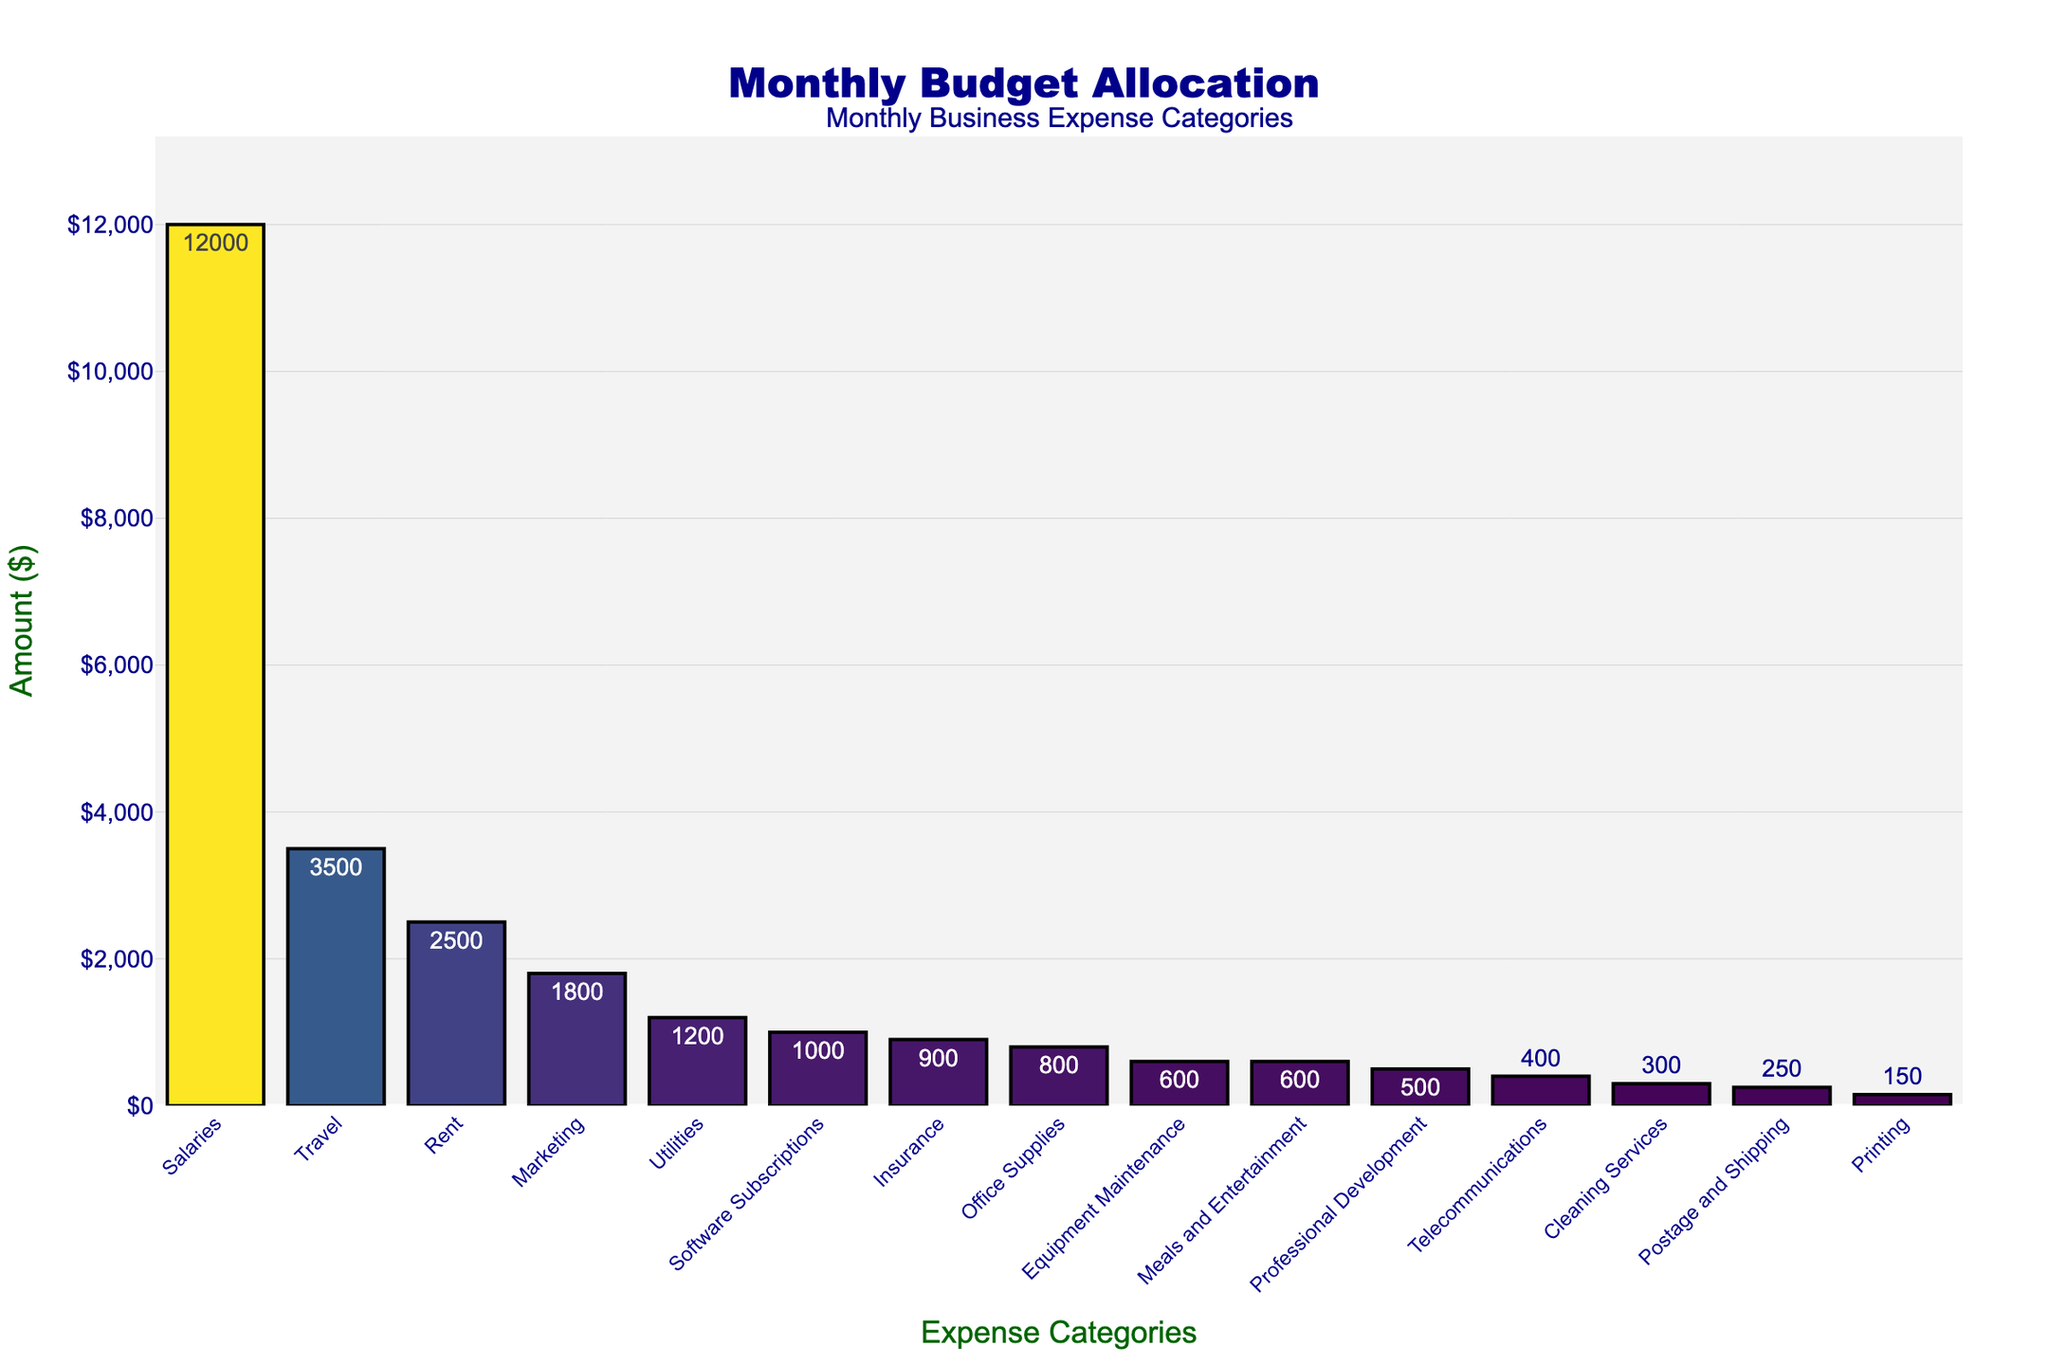Which expense category has the highest budget allocation? The figure shows bars representing each expense category with their respective amounts. The highest bar corresponds to the "Salaries" category.
Answer: Salaries What is the sum of the budget allocated for Travel, Rent, and Marketing? Add the amounts allocated for Travel ($3500), Rent ($2500), and Marketing ($1800). The total is 3500 + 2500 + 1800 = 7800.
Answer: 7800 How much more is allocated to Rent compared to Office Supplies? The amount for Rent is $2500 and for Office Supplies is $800. Subtract the amount for Office Supplies from the amount for Rent: 2500 - 800 = 1700.
Answer: 1700 Which expense categories are allocated less than $500? From the bar chart, the categories with allocations less than $500 are Professional Development, Telecommunications, Cleaning Services, Postage and Shipping, and Printing.
Answer: Professional Development, Telecommunications, Cleaning Services, Postage and Shipping, Printing Which color shade represents the category with the second lowest budget allocation? The second lowest budget allocation corresponds to Printing with $150. This bar is in a darker shade due to the Viridis color scale.
Answer: Dark shade What is the average amount allocated across all expense categories? Sum all the amounts and divide by the number of categories: (3500 + 800 + 1200 + 2500 + 12000 + 1800 + 600 + 1000 + 500 + 400 + 900 + 300 + 250 + 150 + 600) / 15. The total is 25300, and the average is 25300 / 15 ≈ 1687.
Answer: 1687 Is the amount allocated to Marketing higher or lower than the amount for Utilities? The amount for Marketing is $1800 and for Utilities is $1200. Since 1800 is greater than 1200, Marketing has a higher budget.
Answer: Higher What is the difference between the highest and lowest budget allocations? The highest allocation is for Salaries ($12000) and the lowest is for Printing ($150). Subtract the smallest amount from the largest: 12000 - 150 = 11850.
Answer: 11850 